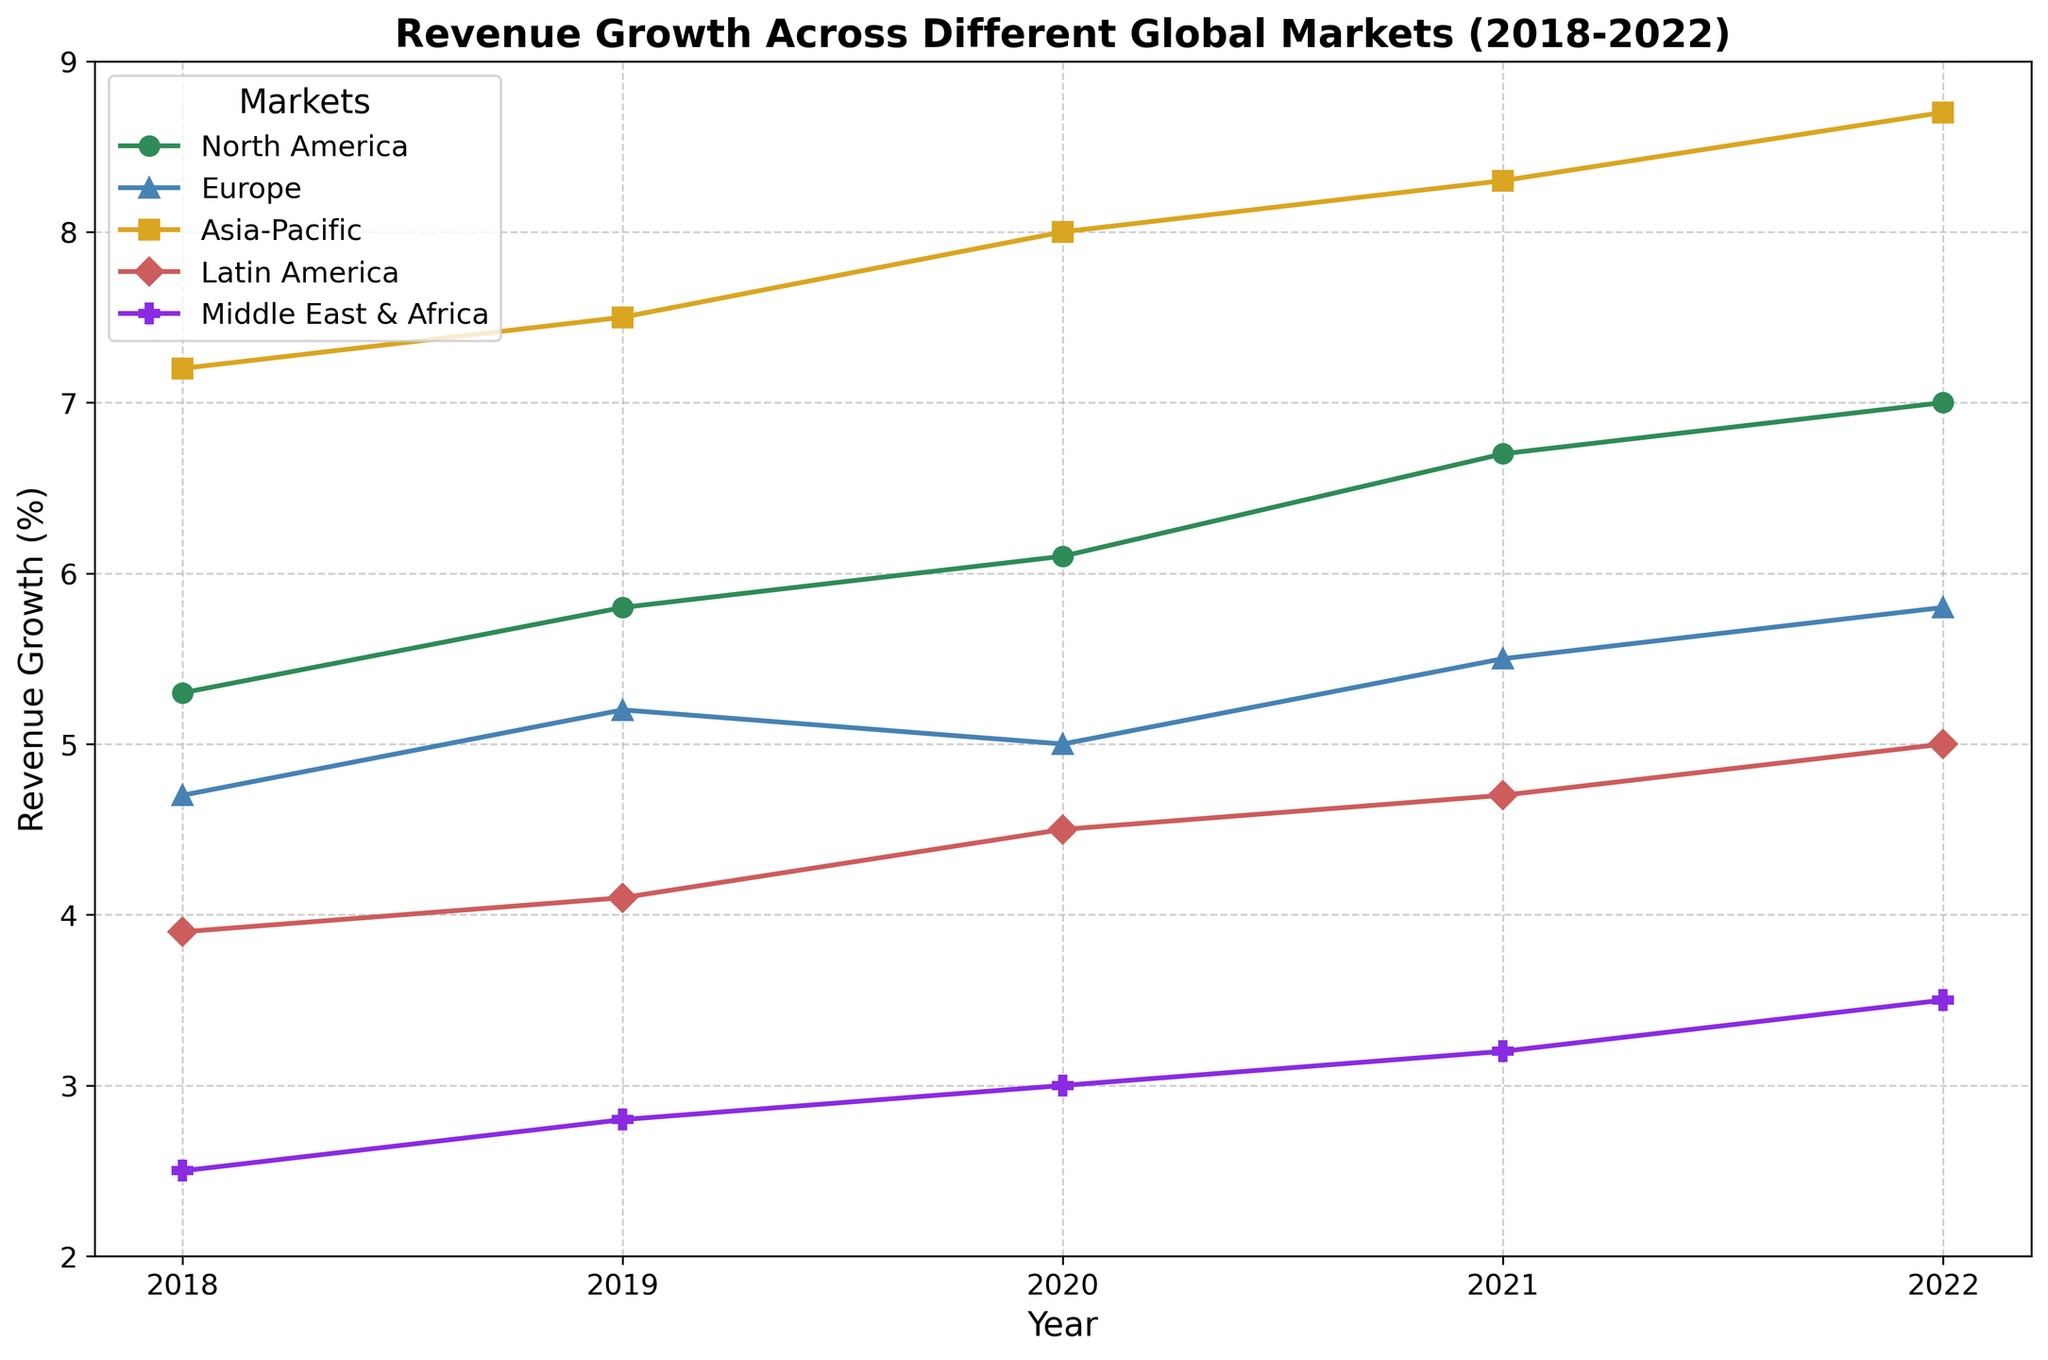What is the market with the highest revenue growth in 2022? Look for the tallest line marker in the year 2022. The market with the highest value is Asia-Pacific.
Answer: Asia-Pacific Which market had the lowest revenue growth in 2018? Look for the shortest line marker in the year 2018. The market with the lowest value is Middle East & Africa.
Answer: Middle East & Africa Compare the revenue growth of North America and Europe in 2020. Which one was higher, and by how much? Locate the line markers for North America and Europe in 2020. North America's value is 6.1 and Europe's value is 5.0. The difference is 6.1 - 5.0.
Answer: North America, 1.1 What is the overall revenue growth trend for Latin America from 2018 to 2022? Observe the progression of the line markers for Latin America from 2018 to 2022. Its growth is increasing steadily.
Answer: Increasing steadily Which two markets showed the most similar revenue growth patterns over the years 2018 to 2022? Compare the trends of all markets. North America and Europe both show a similar steady increase with occasional dips/increases aligning.
Answer: North America and Europe What is the average revenue growth for Asia-Pacific from 2018 to 2022? Calculate the average for Asia-Pacific: (7.2 + 7.5 + 8.0 + 8.3 + 8.7) / 5 = 7.94.
Answer: 7.94 By how much did the revenue growth in the Middle East & Africa increase from 2018 to 2022? Subtract the 2018 value from the 2022 value for Middle East & Africa: 3.5 - 2.5 = 1.0.
Answer: 1.0 In which year did Europe experience the smallest growth? Identify the lowest point in the Europe line plot. It occurs in 2020 with a value of 5.0.
Answer: 2020 What is the difference in revenue growth between the market with the highest growth and the market with the lowest growth in 2021? In 2021, Asia-Pacific has the highest growth (8.3) and Middle East & Africa has the lowest (3.2). The difference is 8.3 - 3.2 = 5.1
Answer: 5.1 